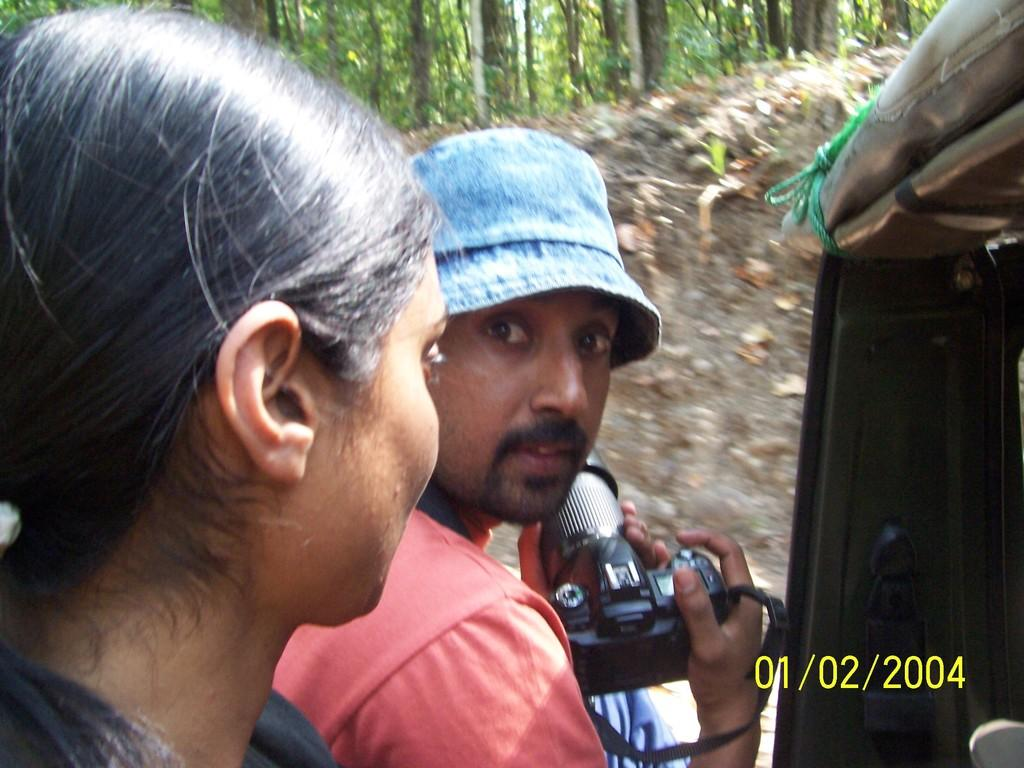What is the man in the image holding in his hand? The man is holding a camera in his hand. What is the woman in the image doing? The woman is standing. What type of vegetation is visible in the image? There are trees visible in the image. How many cakes are being advertised in the image? There are no cakes or advertisements present in the image. What type of bulb is being used by the woman in the image? There is no bulb visible in the image; the woman is simply standing. 